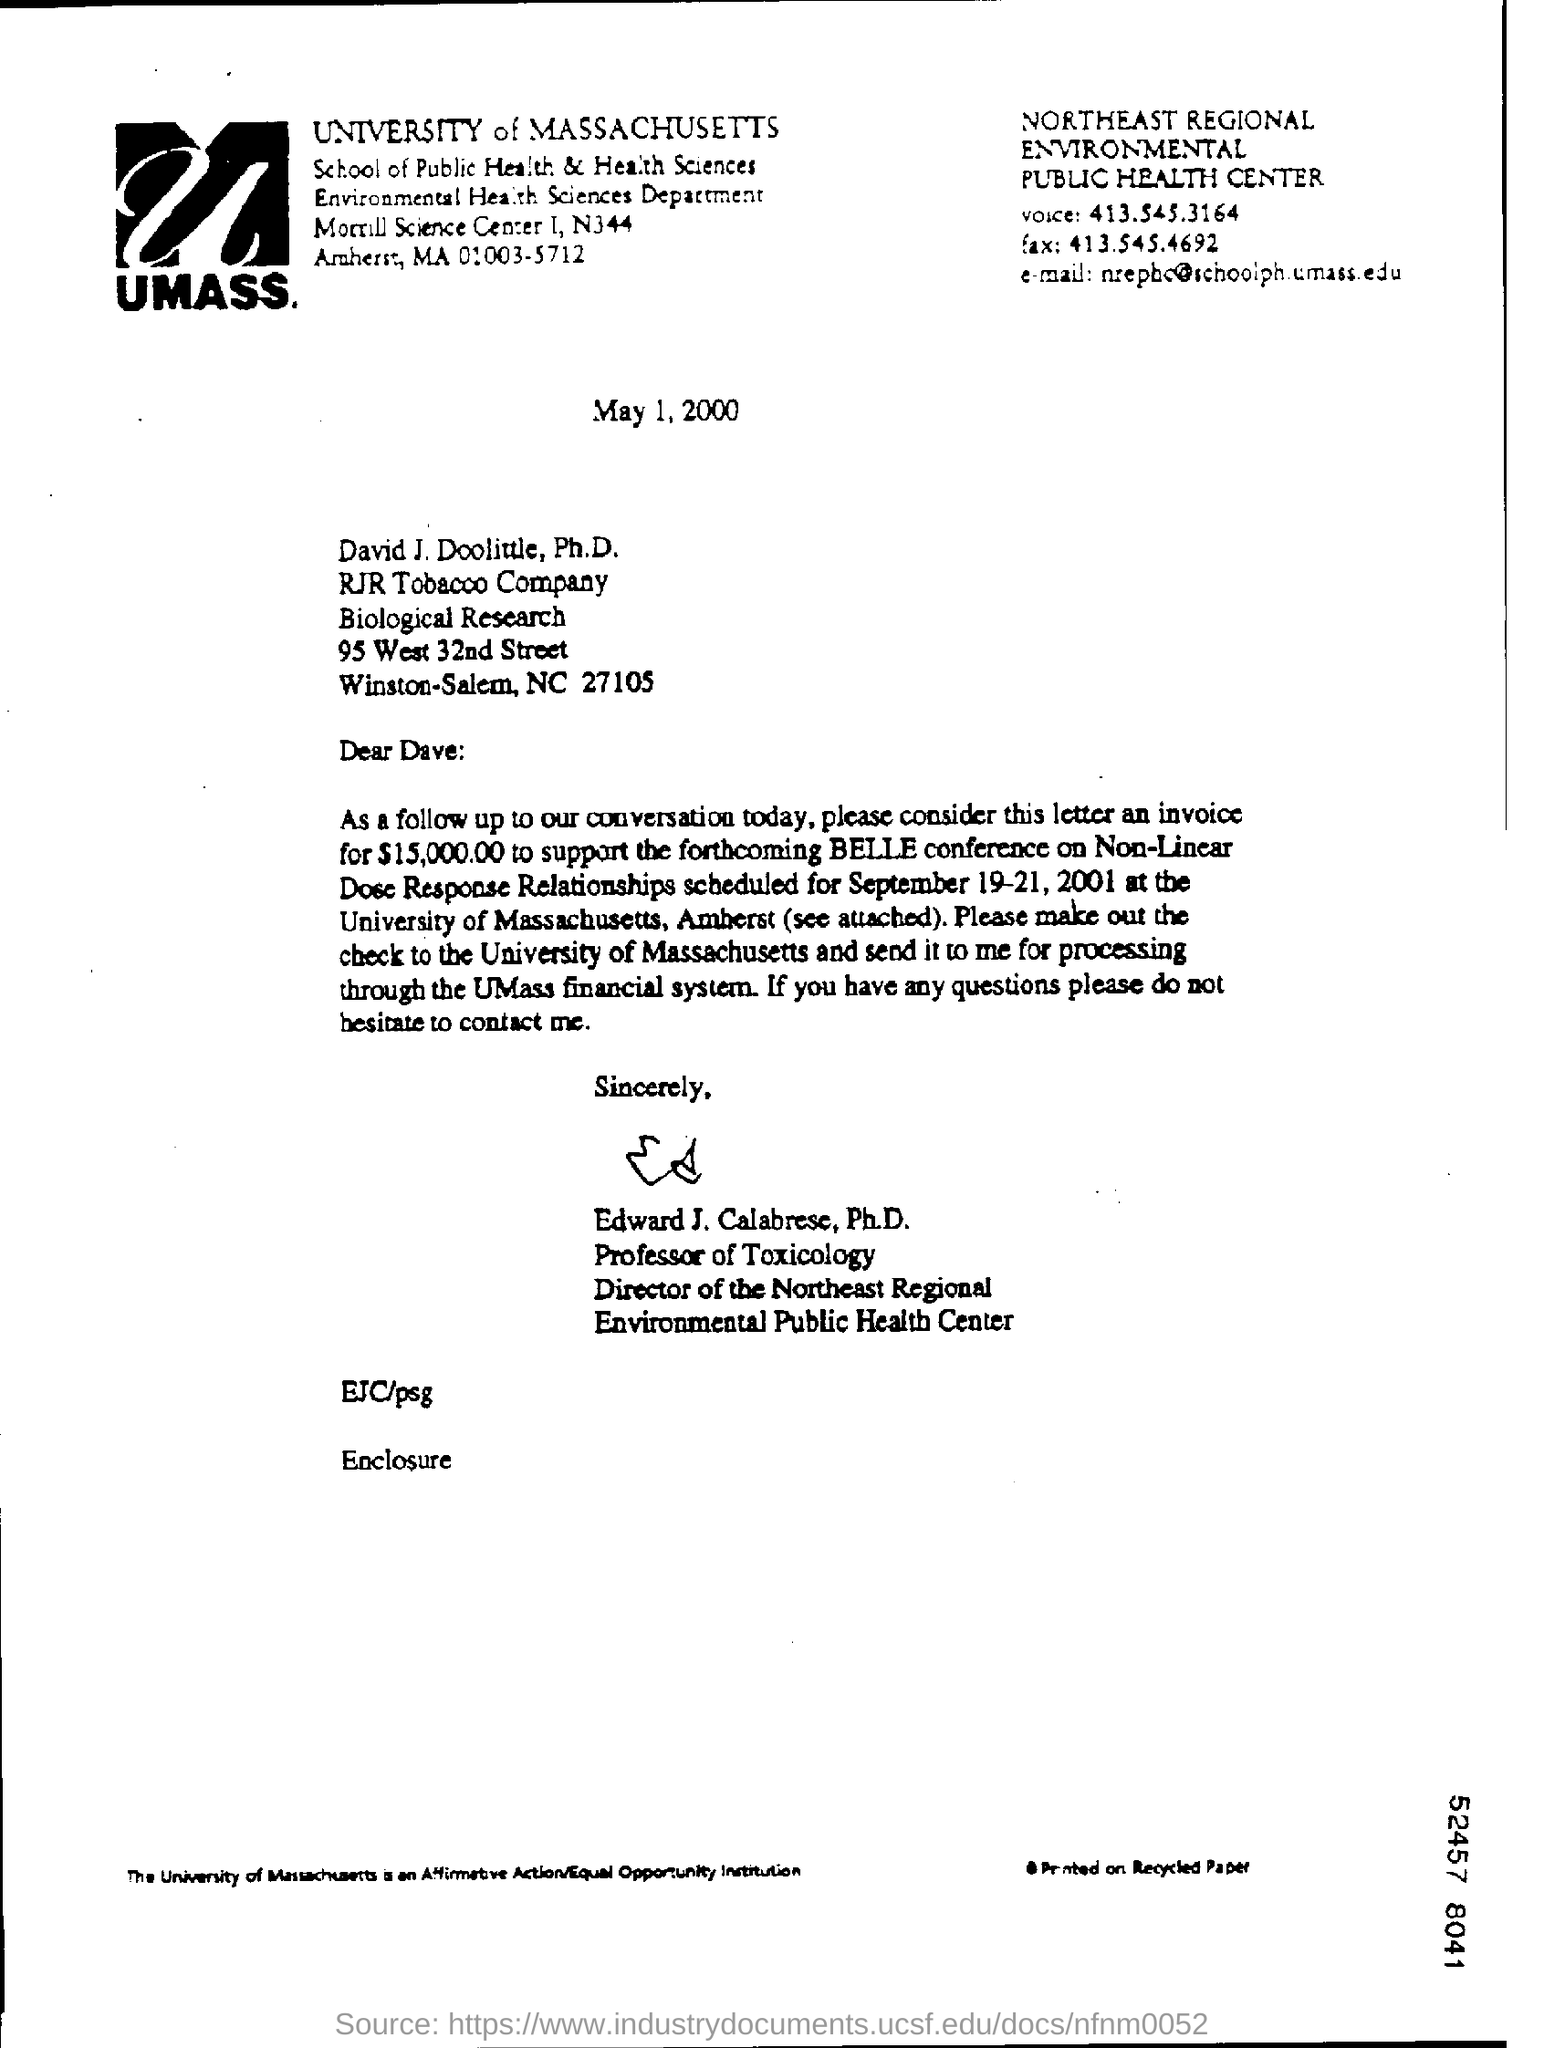Specify some key components in this picture. The salutation of the letter is "Dear Dave:... The invoice amount is 15,000.00. The document was created on May 1, 2000. The writer of this letter is Edward J. Calabrese, Ph.D. 